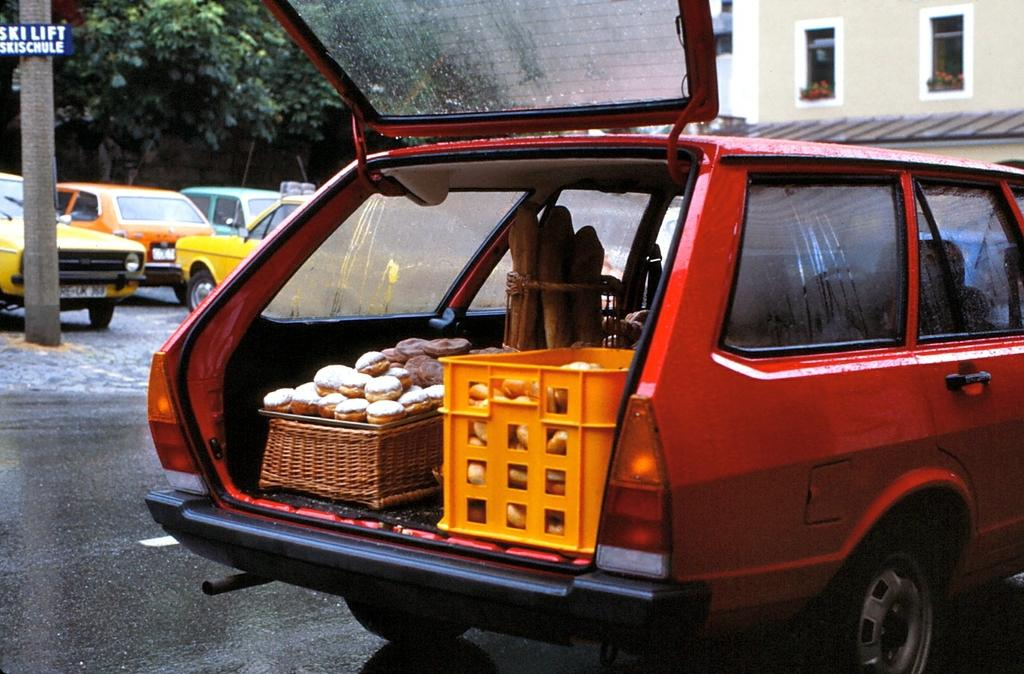<image>
Write a terse but informative summary of the picture. A car has its trunk open in front of a pole with a sign for the ski lift and ski schedule. 